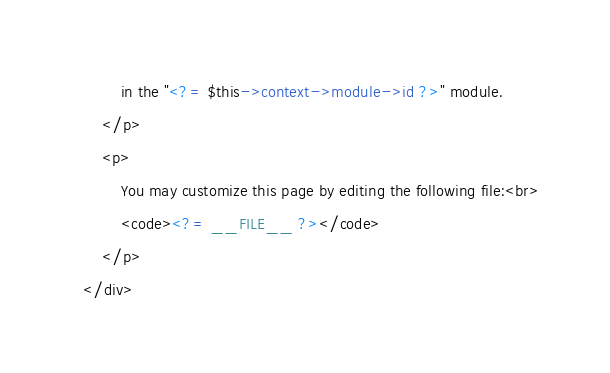Convert code to text. <code><loc_0><loc_0><loc_500><loc_500><_PHP_>        in the "<?= $this->context->module->id ?>" module.
    </p>
    <p>
        You may customize this page by editing the following file:<br>
        <code><?= __FILE__ ?></code>
    </p>
</div>
</code> 